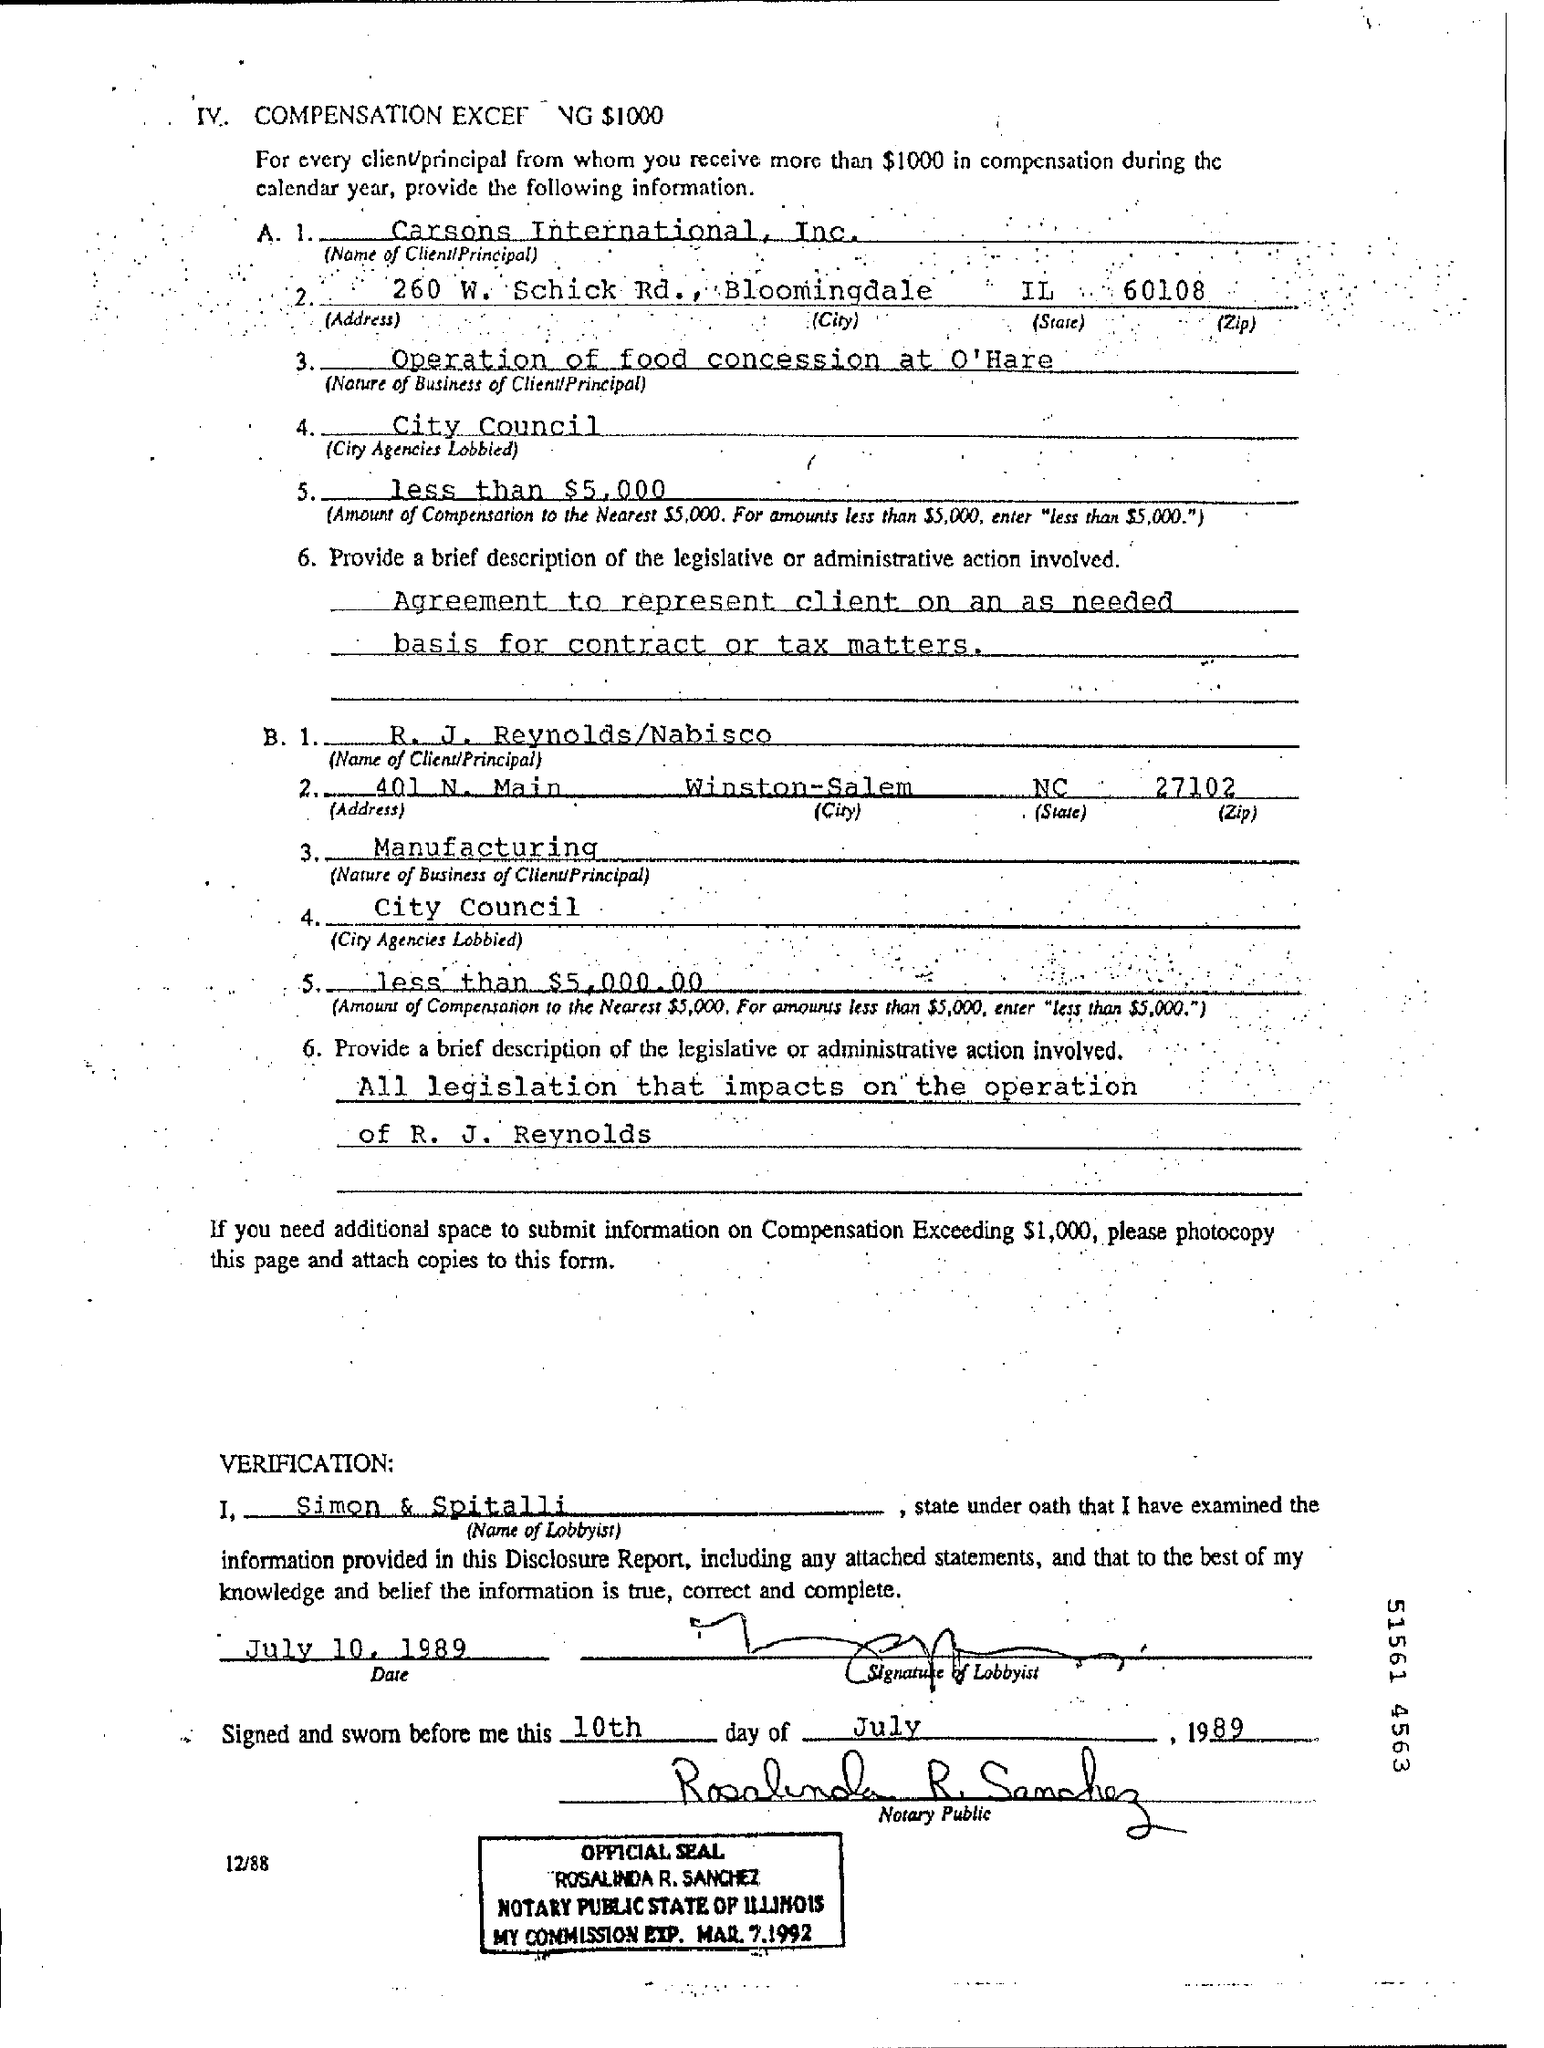Outline some significant characteristics in this image. The lobbyist who examined the information provided was Simon & Spitalli. Carsons International, Inc. is the first client. I received less than $5,000 in compensation from Carson. The second client is from Winston-Salem. 